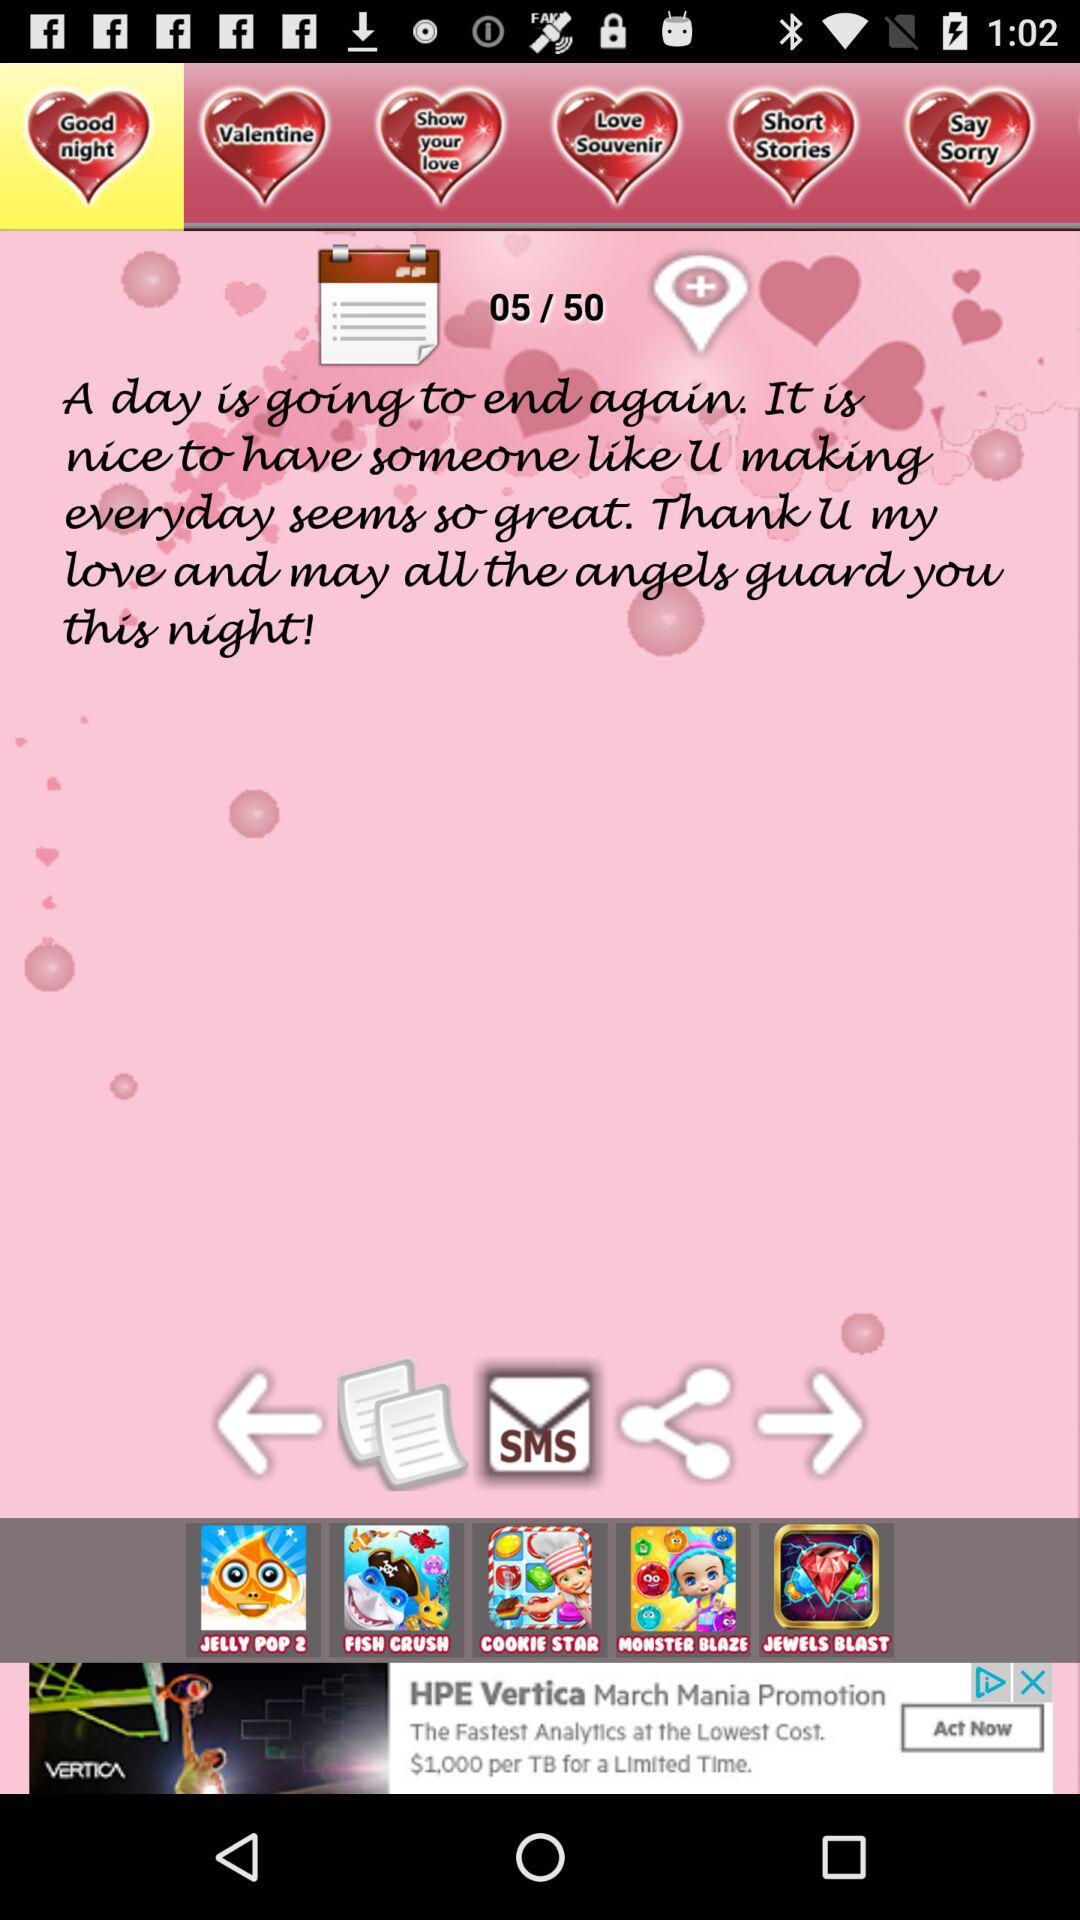How many pages in total are there? There are 50 pages. 